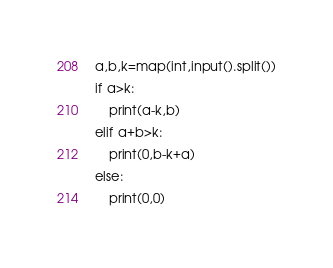<code> <loc_0><loc_0><loc_500><loc_500><_Python_>a,b,k=map(int,input().split())
if a>k:
    print(a-k,b)
elif a+b>k:
    print(0,b-k+a)
else:    
    print(0,0)
</code> 